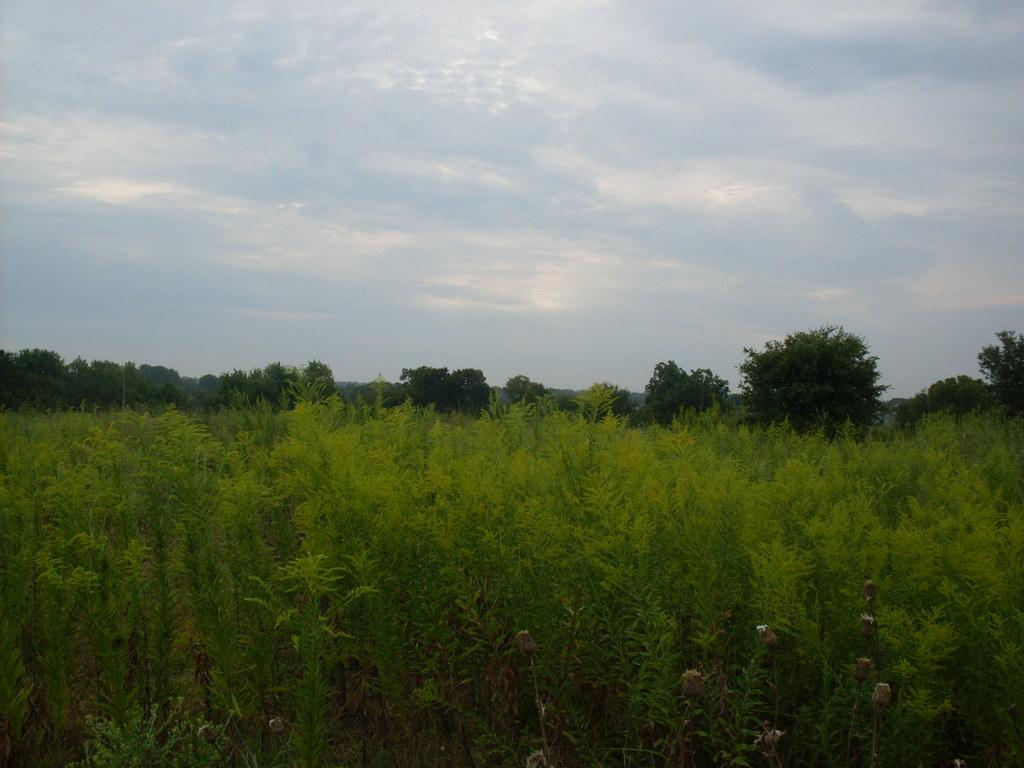What type of vegetation can be seen in the image? There are plants and trees in the image. What part of the natural environment is visible in the image? The sky is visible in the background of the image. Reasoning: Let' Let's think step by step in order to produce the conversation. We start by identifying the main subjects in the image, which are the plants and trees. Then, we expand the conversation to include the sky, which is visible in the background. Each question is designed to elicit a specific detail about the image that is known from the provided facts. Absurd Question/Answer: What type of knife is being used to cut the trees in the image? There is no knife present in the image, and no trees are being cut. 